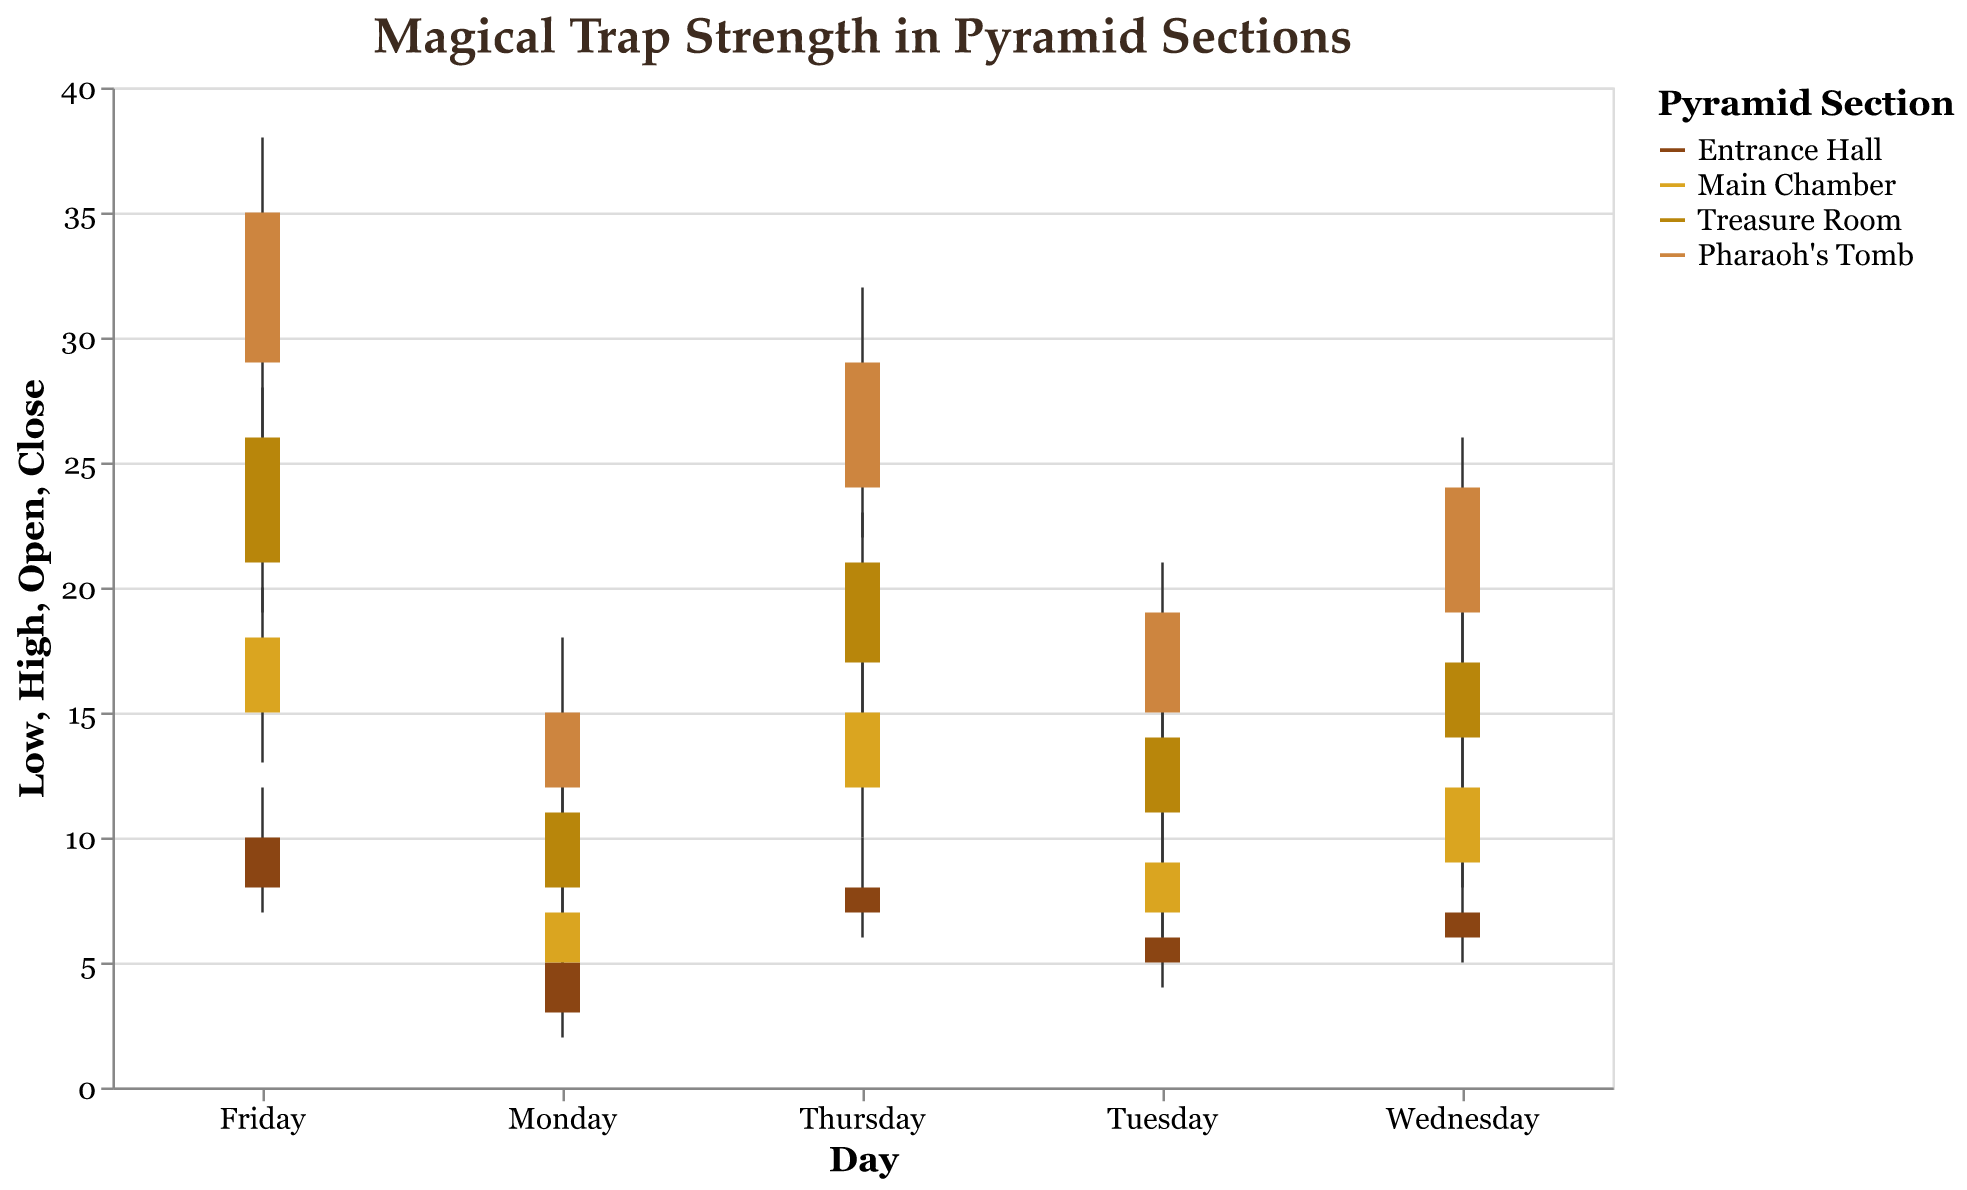What is the highest trap strength recorded in the Pharaoh's Tomb section on Friday? The highest trap strength for the Pharaoh's Tomb section on Friday is represented by the "High" value, which is 38.
Answer: 38 Which section shows the most significant increase in trap strength from Monday to Friday? Observe the "Open" value on Monday and the "Close" value on Friday for each section. Calculate the increase for each: 
- Entrance Hall: 10 - 3 = 7
- Main Chamber: 18 - 5 = 13
- Treasure Room: 26 - 8 = 18
- Pharaoh's Tomb: 35 - 12 = 23
The Pharaoh's Tomb has the most significant increase of 23.
Answer: Pharaoh's Tomb On which day does the Entrance Hall section have the lowest recorded trap strength? For the Entrance Hall, compare all the "Low" values over the week.
- Monday: 2
- Tuesday: 4
- Wednesday: 5
- Thursday: 6
- Friday: 7
The lowest recorded trap strength is 2, which occurs on Monday.
Answer: Monday What is the range of trap strengths observed in the Main Chamber on Thursday? The range is calculated by subtracting the "Low" value from the "High" value. For the Main Chamber on Thursday: 17 - 10 = 7.
Answer: 7 Which day records the greatest difference between the highest and lowest trap strengths across all sections? Calculate the difference (High - Low) for each day across all sections and identify the day with the highest difference:
- Monday: Max: 18, Min: 2, Difference = 16
- Tuesday: Max: 21, Min: 4, Difference = 17
- Wednesday: Max: 26, Min: 5, Difference = 21
- Thursday: Max: 32, Min: 6, Difference = 26
- Friday: Max: 38, Min: 7, Difference = 31
Friday has the greatest difference of 31.
Answer: Friday How does the trap strength trend over the week in the Treasure Room? Observing the "Close" values in the Treasure Room from Monday to Friday:
- Monday: 11
- Tuesday: 14
- Wednesday: 17
- Thursday: 21
- Friday: 26
The trap strength increases each day, showing a rising trend.
Answer: Rising trend Which section has the highest variance in trap strengths on Friday? Calculate the range (High - Low) for each section on Friday:
- Entrance Hall: 12 - 7 = 5
- Main Chamber: 20 - 13 = 7
- Treasure Room: 28 - 19 = 9
- Pharaoh's Tomb: 38 - 26 = 12
Pharaoh's Tomb has the highest variance of 12.
Answer: Pharaoh's Tomb What is the average "Close" value on Wednesday for all sections? Sum the "Close" values on Wednesday for all sections and divide by the number of sections:
- Entrance Hall: 7
- Main Chamber: 12
- Treasure Room: 17
- Pharaoh's Tomb: 24
Total = 7 + 12 + 17 + 24 = 60, Average = 60 / 4 = 15
Answer: 15 